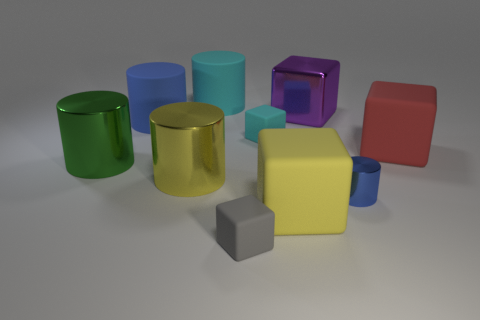How many yellow objects are either blocks or tiny matte things?
Your answer should be very brief. 1. What color is the large matte thing that is behind the big green thing and on the right side of the big cyan cylinder?
Ensure brevity in your answer.  Red. What number of large objects are either brown matte blocks or blue matte objects?
Give a very brief answer. 1. What is the size of the cyan matte thing that is the same shape as the blue metal object?
Ensure brevity in your answer.  Large. The small gray thing has what shape?
Your answer should be very brief. Cube. Are the small gray cube and the large cylinder that is to the right of the yellow metal object made of the same material?
Offer a very short reply. Yes. What number of matte objects are either tiny brown spheres or yellow objects?
Your answer should be compact. 1. What size is the blue object in front of the blue rubber thing?
Ensure brevity in your answer.  Small. What size is the yellow thing that is the same material as the small gray thing?
Ensure brevity in your answer.  Large. How many rubber objects have the same color as the tiny shiny cylinder?
Your response must be concise. 1. 